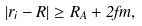<formula> <loc_0><loc_0><loc_500><loc_500>| { r } _ { i } - { R } | \geq R _ { A } + 2 f m ,</formula> 